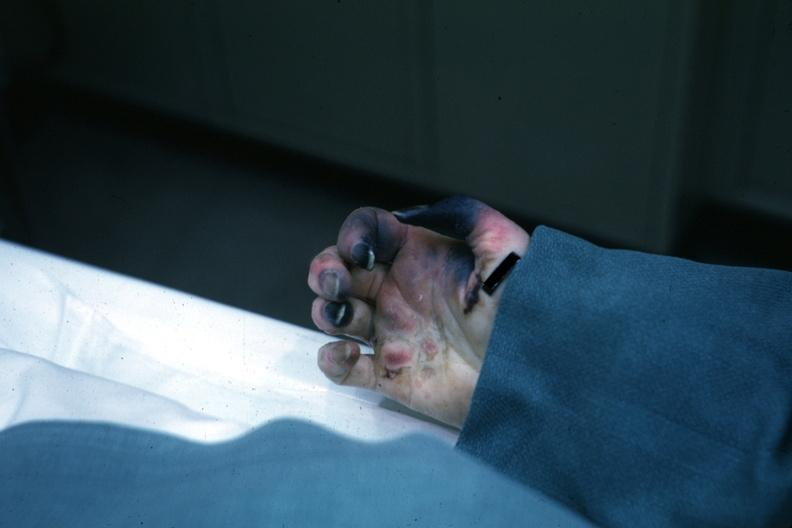what know shock vs emboli?
Answer the question using a single word or phrase. Exact cause 